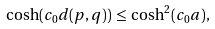Convert formula to latex. <formula><loc_0><loc_0><loc_500><loc_500>\cosh ( c _ { 0 } d ( p , q ) ) \, \leq \, \cosh ^ { 2 } ( c _ { 0 } a ) ,</formula> 